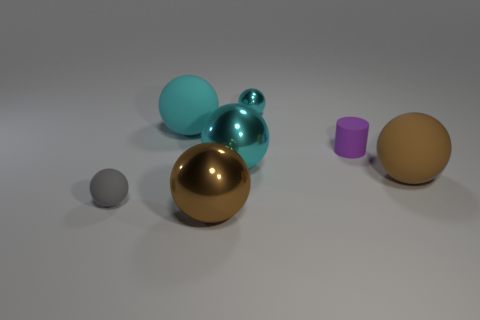Subtract all blue cubes. How many cyan balls are left? 3 Subtract all tiny gray spheres. How many spheres are left? 5 Add 2 purple rubber cylinders. How many objects exist? 9 Subtract all brown balls. How many balls are left? 4 Subtract 3 spheres. How many spheres are left? 3 Subtract all gray spheres. Subtract all cyan cylinders. How many spheres are left? 5 Subtract 1 purple cylinders. How many objects are left? 6 Subtract all balls. How many objects are left? 1 Subtract all gray rubber things. Subtract all tiny metal objects. How many objects are left? 5 Add 4 brown matte things. How many brown matte things are left? 5 